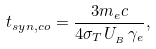<formula> <loc_0><loc_0><loc_500><loc_500>t _ { s y n , c o } = \frac { 3 m _ { e } c } { 4 \sigma _ { T } U _ { _ { B } } \, \gamma _ { e } } ,</formula> 